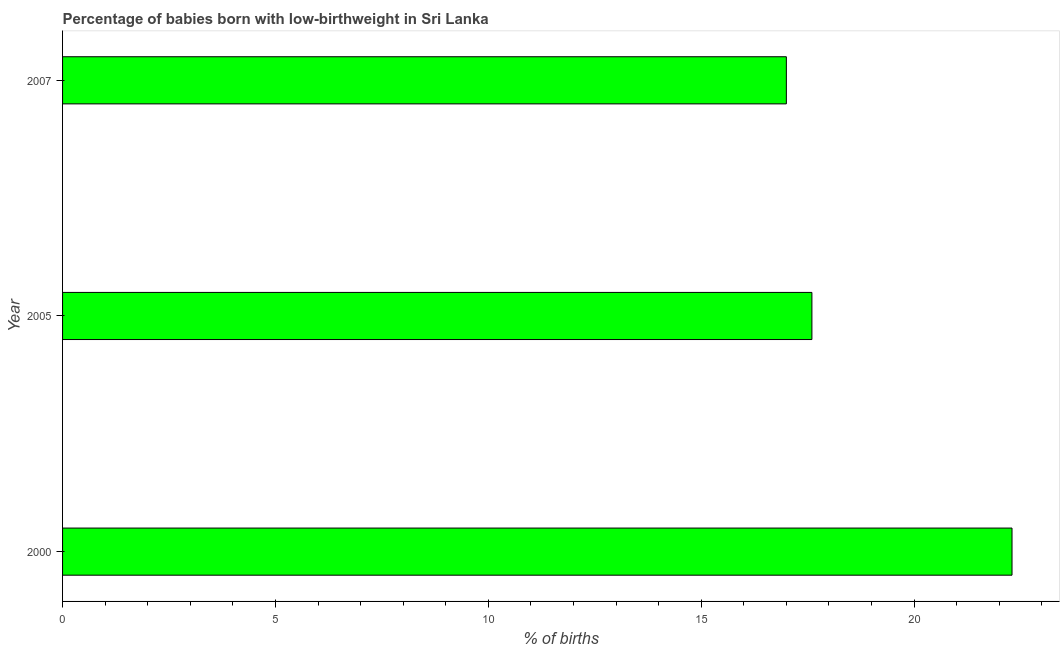Does the graph contain grids?
Provide a short and direct response. No. What is the title of the graph?
Keep it short and to the point. Percentage of babies born with low-birthweight in Sri Lanka. What is the label or title of the X-axis?
Make the answer very short. % of births. What is the label or title of the Y-axis?
Make the answer very short. Year. What is the percentage of babies who were born with low-birthweight in 2000?
Give a very brief answer. 22.3. Across all years, what is the maximum percentage of babies who were born with low-birthweight?
Your answer should be compact. 22.3. Across all years, what is the minimum percentage of babies who were born with low-birthweight?
Ensure brevity in your answer.  17. In which year was the percentage of babies who were born with low-birthweight maximum?
Ensure brevity in your answer.  2000. In which year was the percentage of babies who were born with low-birthweight minimum?
Provide a short and direct response. 2007. What is the sum of the percentage of babies who were born with low-birthweight?
Your response must be concise. 56.9. What is the average percentage of babies who were born with low-birthweight per year?
Your answer should be very brief. 18.97. What is the median percentage of babies who were born with low-birthweight?
Offer a very short reply. 17.6. Do a majority of the years between 2007 and 2005 (inclusive) have percentage of babies who were born with low-birthweight greater than 2 %?
Your response must be concise. No. What is the ratio of the percentage of babies who were born with low-birthweight in 2000 to that in 2005?
Your answer should be very brief. 1.27. Is the sum of the percentage of babies who were born with low-birthweight in 2000 and 2005 greater than the maximum percentage of babies who were born with low-birthweight across all years?
Keep it short and to the point. Yes. What is the difference between the highest and the lowest percentage of babies who were born with low-birthweight?
Your answer should be very brief. 5.3. In how many years, is the percentage of babies who were born with low-birthweight greater than the average percentage of babies who were born with low-birthweight taken over all years?
Keep it short and to the point. 1. How many years are there in the graph?
Offer a very short reply. 3. Are the values on the major ticks of X-axis written in scientific E-notation?
Your response must be concise. No. What is the % of births in 2000?
Offer a very short reply. 22.3. What is the difference between the % of births in 2000 and 2007?
Make the answer very short. 5.3. What is the ratio of the % of births in 2000 to that in 2005?
Offer a terse response. 1.27. What is the ratio of the % of births in 2000 to that in 2007?
Keep it short and to the point. 1.31. What is the ratio of the % of births in 2005 to that in 2007?
Your response must be concise. 1.03. 